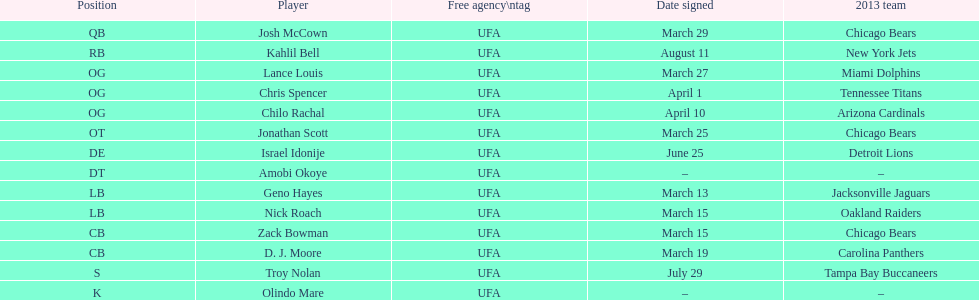What is the aggregate number of teams in the 2013 chart? 10. 